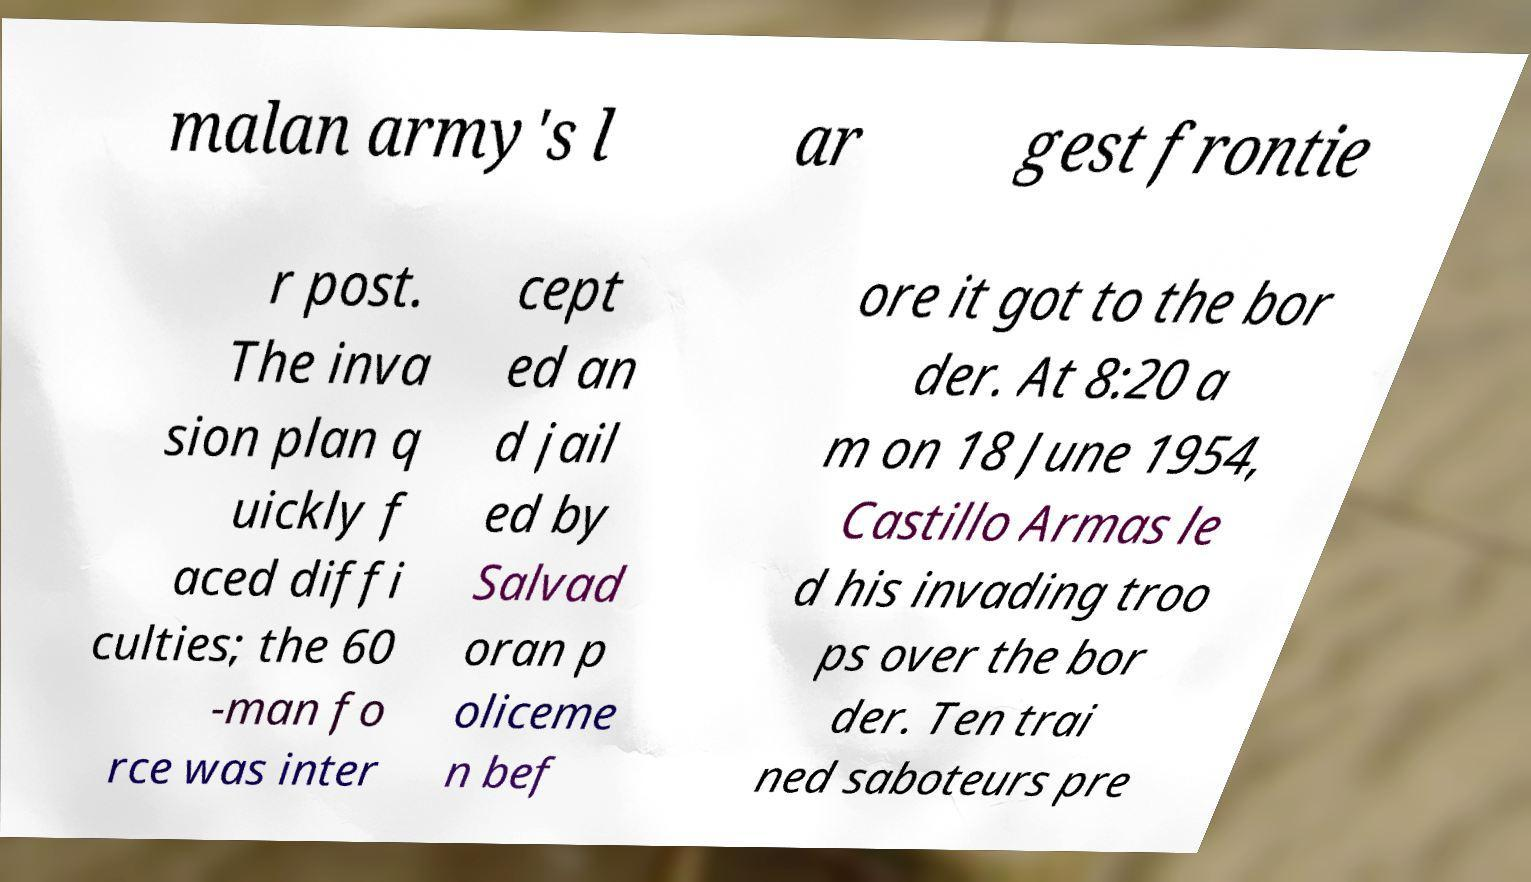Please read and relay the text visible in this image. What does it say? malan army's l ar gest frontie r post. The inva sion plan q uickly f aced diffi culties; the 60 -man fo rce was inter cept ed an d jail ed by Salvad oran p oliceme n bef ore it got to the bor der. At 8:20 a m on 18 June 1954, Castillo Armas le d his invading troo ps over the bor der. Ten trai ned saboteurs pre 